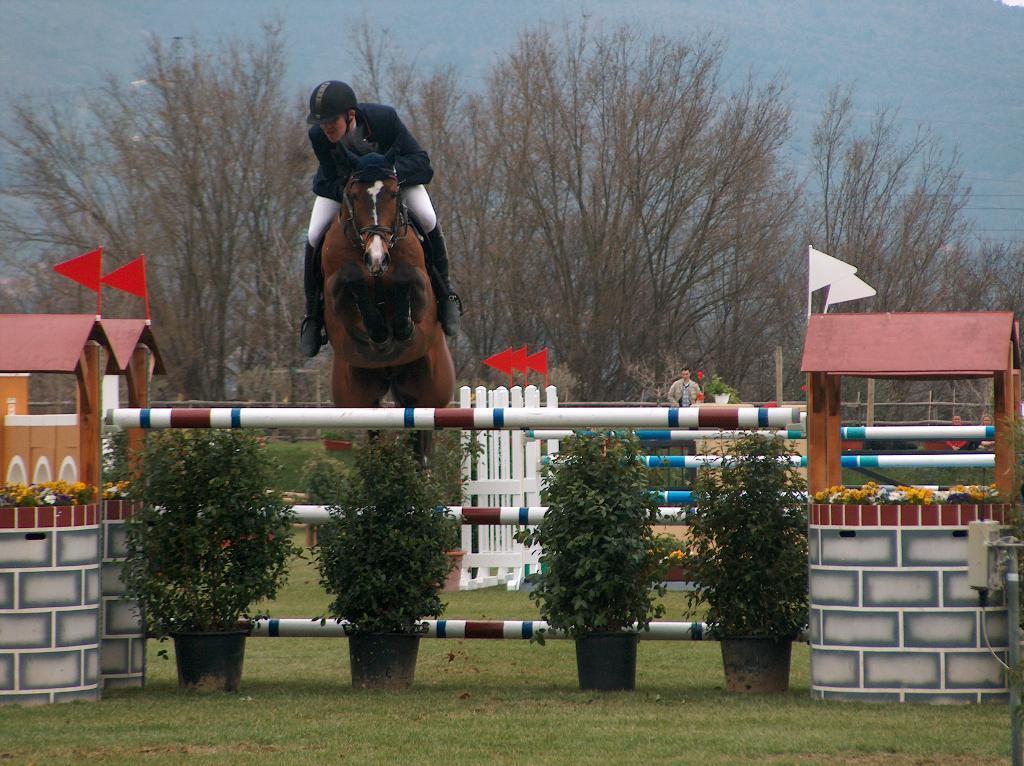Please provide a concise description of this image. In this image we can see a man riding a horse. We can also see some poles, plants in the pots, grass, some toy houses with roof and the flags, some plants with flowers and a fence. On the backside we can see a group of trees, a person standing and the sky which looks cloudy. 